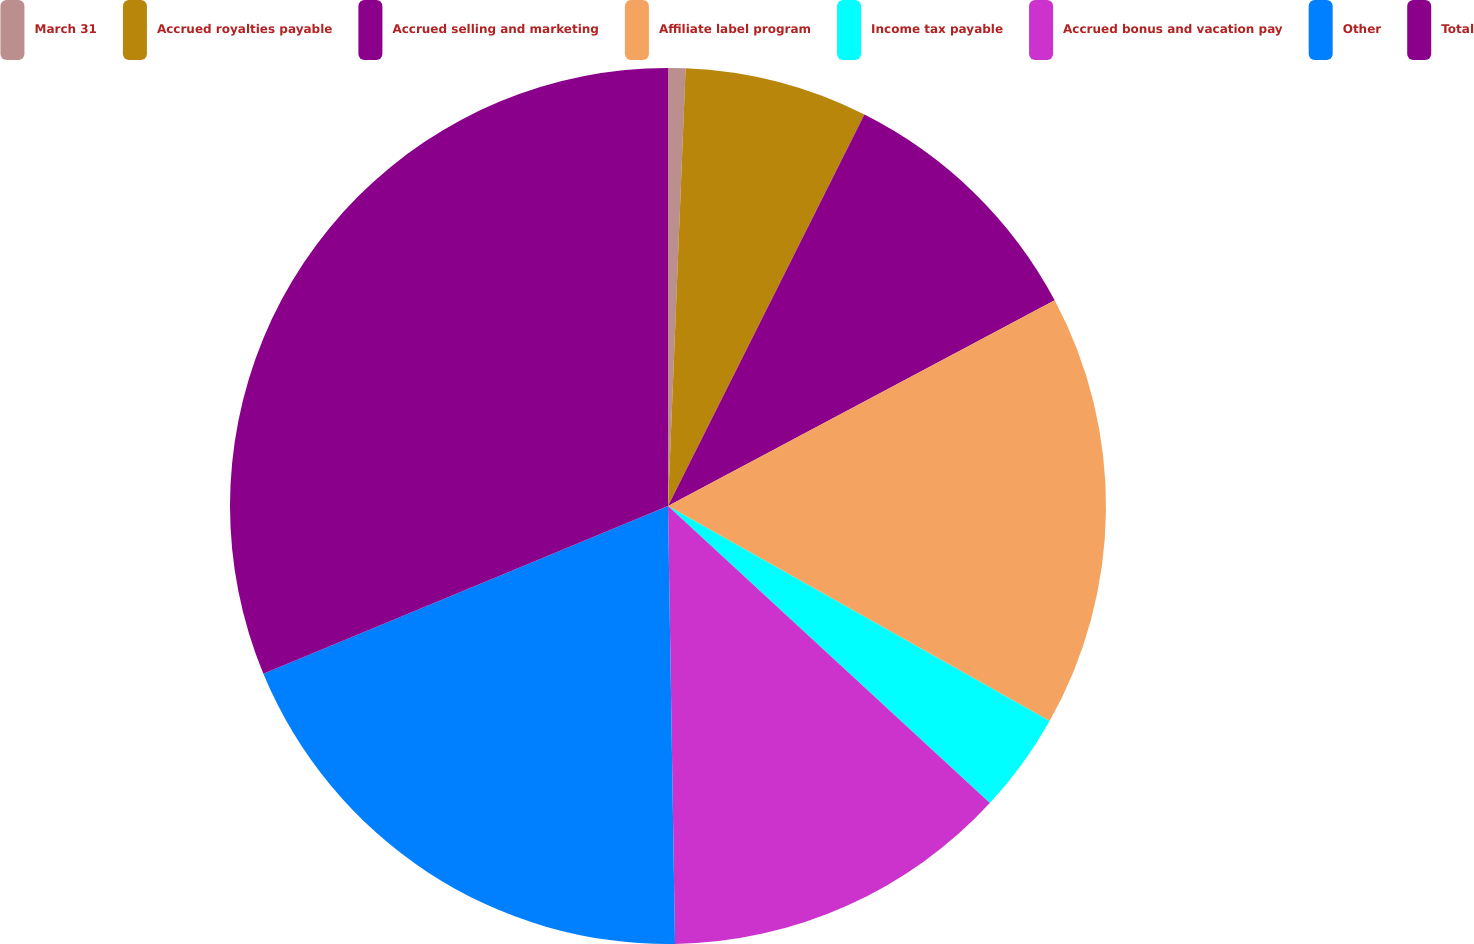<chart> <loc_0><loc_0><loc_500><loc_500><pie_chart><fcel>March 31<fcel>Accrued royalties payable<fcel>Accrued selling and marketing<fcel>Affiliate label program<fcel>Income tax payable<fcel>Accrued bonus and vacation pay<fcel>Other<fcel>Total<nl><fcel>0.64%<fcel>6.76%<fcel>9.82%<fcel>15.94%<fcel>3.7%<fcel>12.88%<fcel>19.0%<fcel>31.25%<nl></chart> 